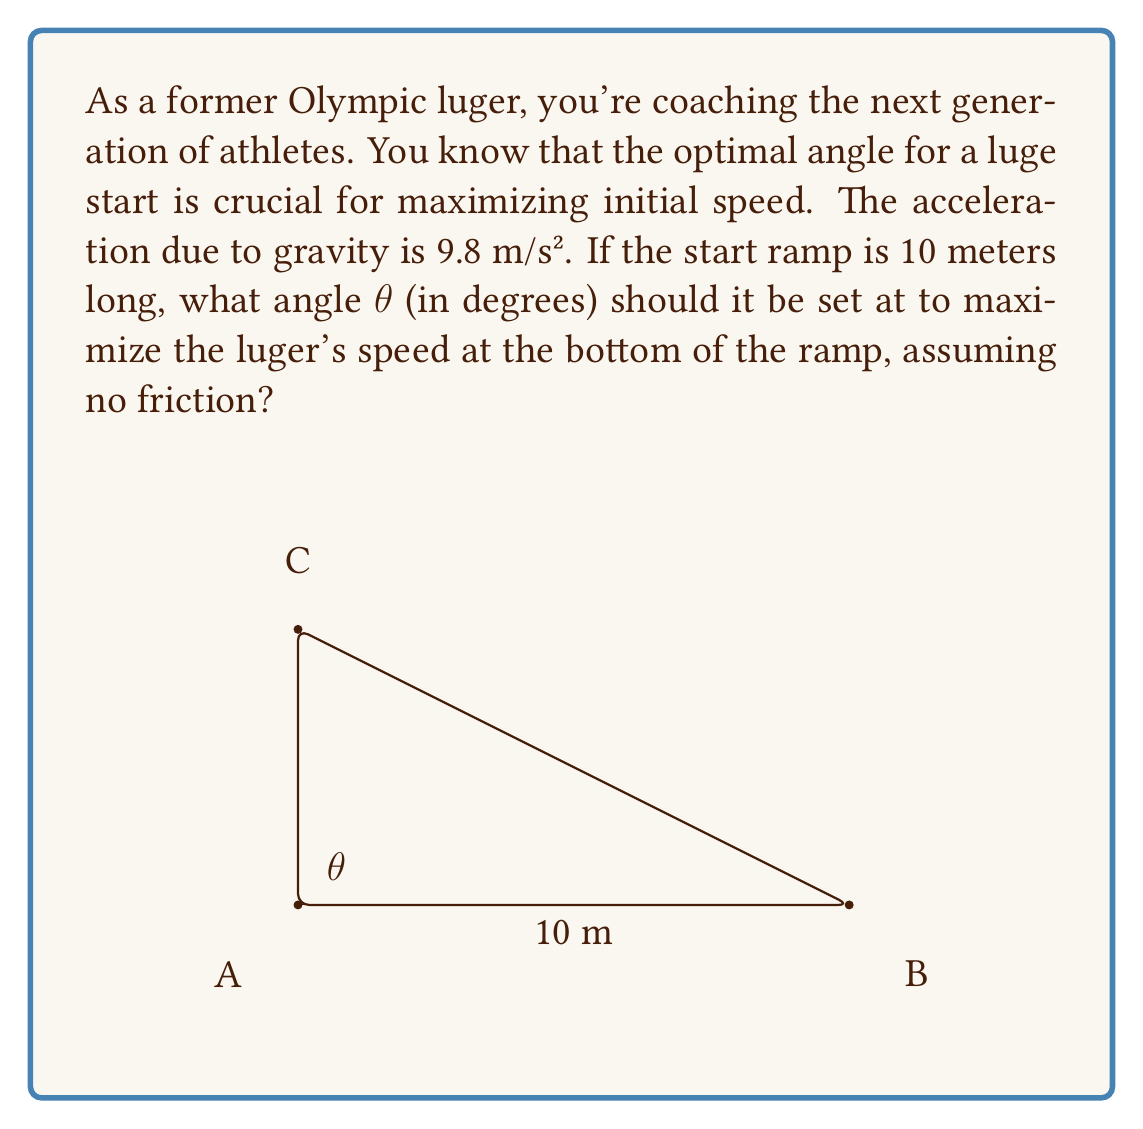Can you answer this question? To solve this problem, we'll use the principle of conservation of energy and the equation for acceleration along an inclined plane.

Step 1: Express the potential energy at the top of the ramp.
$PE = mgh$, where $m$ is mass, $g$ is gravity, and $h$ is height.
$h = 10 \sin(\theta)$, so $PE = 10mg \sin(\theta)$

Step 2: Express the kinetic energy at the bottom of the ramp.
$KE = \frac{1}{2}mv^2$, where $v$ is velocity.

Step 3: By conservation of energy, $PE = KE$
$10mg \sin(\theta) = \frac{1}{2}mv^2$

Step 4: Solve for $v$
$v = \sqrt{20g \sin(\theta)}$

Step 5: To maximize $v$, we need to maximize $\sin(\theta)$. The maximum value of $\sin(\theta)$ occurs when $\theta = 90°$. However, this would result in a vertical drop, which is not practical for a luge ramp.

Step 6: In reality, we need to consider the acceleration along the ramp. The acceleration along an inclined plane is given by:
$a = g \sin(\theta)$

Step 7: The distance traveled along the ramp is given by:
$s = \frac{1}{2}at^2$, where $t$ is time.

Substituting $a$ and $s = 10$ (length of the ramp):
$10 = \frac{1}{2}g \sin(\theta) t^2$

Step 8: Solve for $t$:
$t = \sqrt{\frac{20}{g \sin(\theta)}}$

Step 9: The velocity at the bottom of the ramp is $v = at$:
$v = g \sin(\theta) \sqrt{\frac{20}{g \sin(\theta)}} = \sqrt{20g \sin(\theta)}$

This is the same result we got from the energy method.

Step 10: To maximize $v$, we need to maximize $\sin(\theta)$. The maximum value of $\sin(\theta)$ occurs when $\theta = 90°$. However, this is not practical for a luge ramp.

In practice, the optimal angle is typically around 45°. This provides a good balance between gravitational acceleration and the horizontal distance covered, allowing the luger to build up speed while maintaining control.
Answer: 45° 